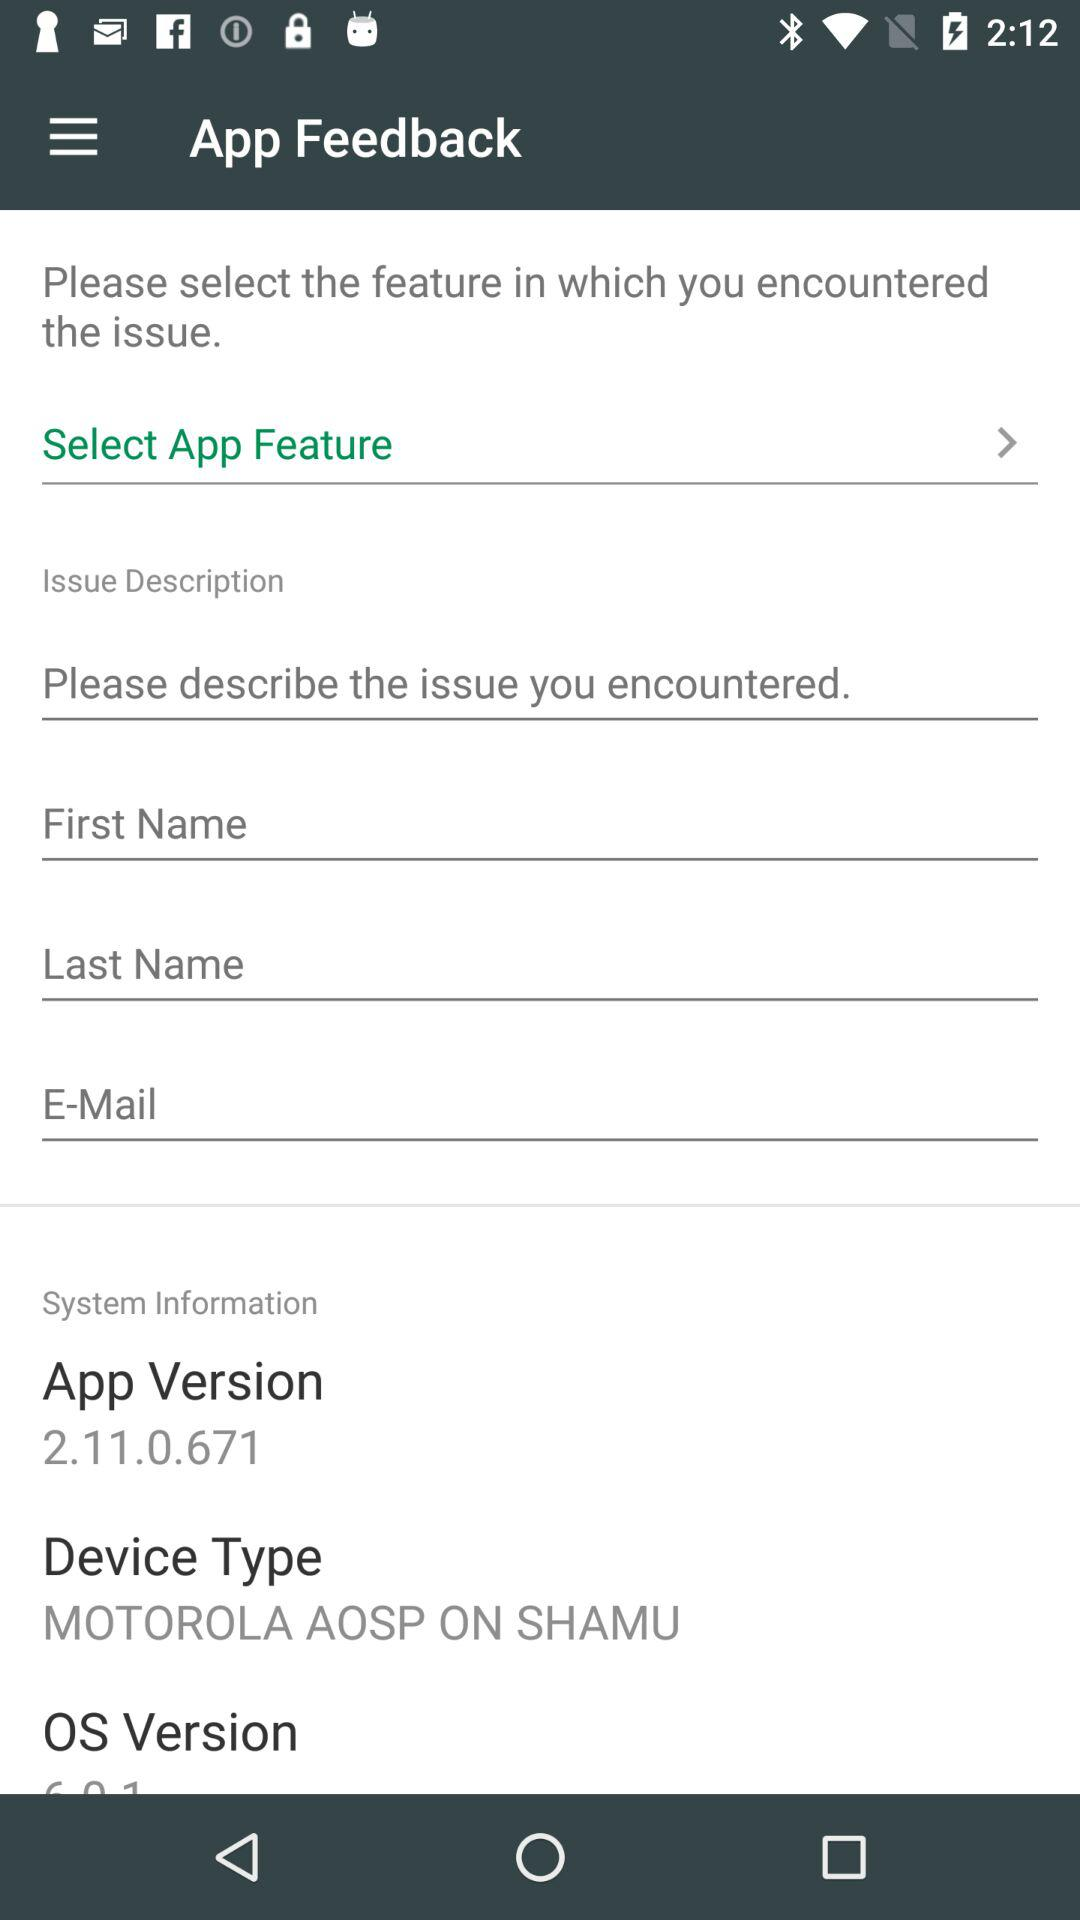What is the device type? The device type is "MOTOROLA AOSP ON SHAMU". 